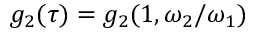Convert formula to latex. <formula><loc_0><loc_0><loc_500><loc_500>g _ { 2 } ( \tau ) = g _ { 2 } ( 1 , \omega _ { 2 } / \omega _ { 1 } )</formula> 